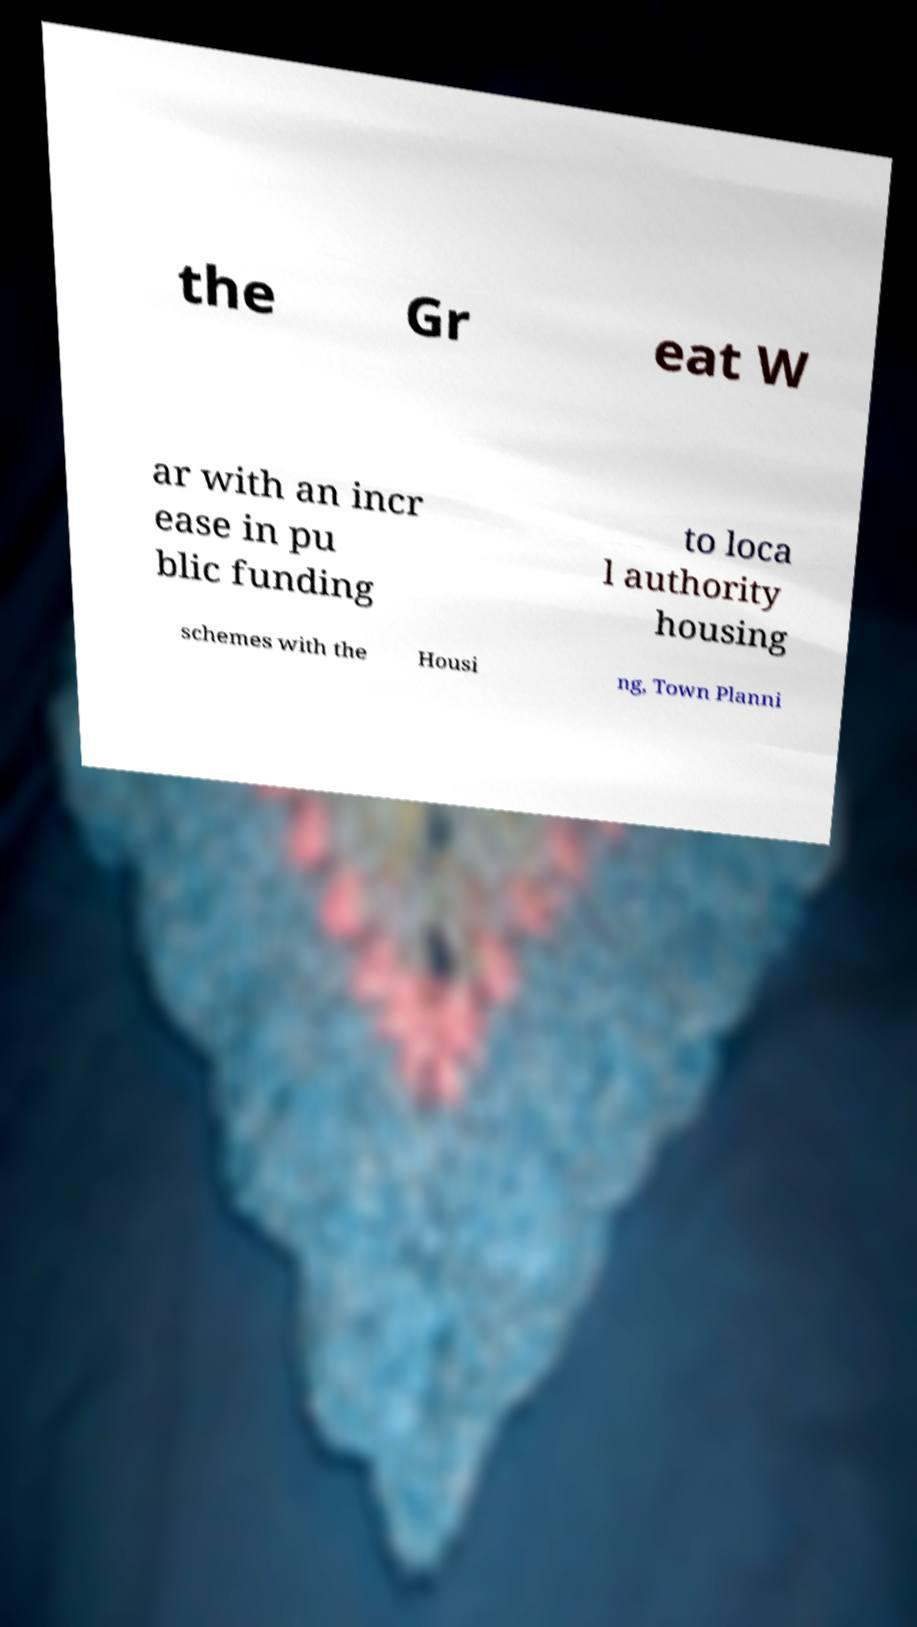Please identify and transcribe the text found in this image. the Gr eat W ar with an incr ease in pu blic funding to loca l authority housing schemes with the Housi ng, Town Planni 